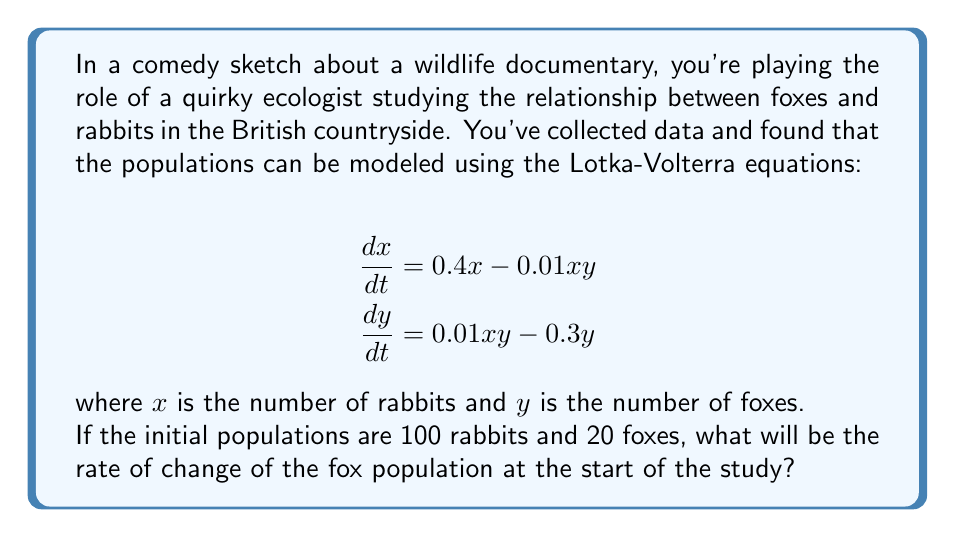Provide a solution to this math problem. To solve this problem, we need to use the Lotka-Volterra equation for the rate of change of the fox population:

$$\frac{dy}{dt} = 0.01xy - 0.3y$$

We're given the initial populations:
$x = 100$ (rabbits)
$y = 20$ (foxes)

Let's substitute these values into the equation:

$$\frac{dy}{dt} = 0.01(100)(20) - 0.3(20)$$

Simplifying:

$$\frac{dy}{dt} = 20 - 6$$

$$\frac{dy}{dt} = 14$$

This result represents the rate of change of the fox population at the start of the study. It's positive, indicating that the fox population is increasing initially.
Answer: The rate of change of the fox population at the start of the study is 14 foxes per time unit. 